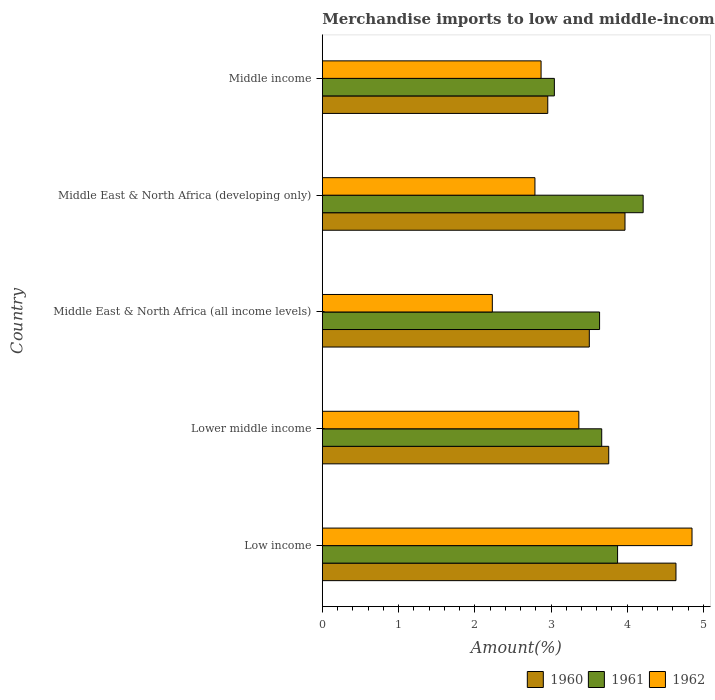How many different coloured bars are there?
Your answer should be very brief. 3. How many bars are there on the 2nd tick from the top?
Your answer should be compact. 3. What is the label of the 2nd group of bars from the top?
Offer a very short reply. Middle East & North Africa (developing only). What is the percentage of amount earned from merchandise imports in 1960 in Middle East & North Africa (developing only)?
Provide a short and direct response. 3.97. Across all countries, what is the maximum percentage of amount earned from merchandise imports in 1962?
Ensure brevity in your answer.  4.85. Across all countries, what is the minimum percentage of amount earned from merchandise imports in 1961?
Keep it short and to the point. 3.04. In which country was the percentage of amount earned from merchandise imports in 1960 maximum?
Your answer should be compact. Low income. In which country was the percentage of amount earned from merchandise imports in 1962 minimum?
Make the answer very short. Middle East & North Africa (all income levels). What is the total percentage of amount earned from merchandise imports in 1961 in the graph?
Offer a very short reply. 18.43. What is the difference between the percentage of amount earned from merchandise imports in 1961 in Low income and that in Middle East & North Africa (all income levels)?
Provide a short and direct response. 0.24. What is the difference between the percentage of amount earned from merchandise imports in 1962 in Lower middle income and the percentage of amount earned from merchandise imports in 1961 in Middle East & North Africa (developing only)?
Offer a terse response. -0.84. What is the average percentage of amount earned from merchandise imports in 1960 per country?
Your answer should be compact. 3.77. What is the difference between the percentage of amount earned from merchandise imports in 1962 and percentage of amount earned from merchandise imports in 1961 in Low income?
Your answer should be very brief. 0.98. In how many countries, is the percentage of amount earned from merchandise imports in 1961 greater than 3.4 %?
Give a very brief answer. 4. What is the ratio of the percentage of amount earned from merchandise imports in 1960 in Middle East & North Africa (developing only) to that in Middle income?
Your answer should be very brief. 1.34. What is the difference between the highest and the second highest percentage of amount earned from merchandise imports in 1961?
Offer a terse response. 0.34. What is the difference between the highest and the lowest percentage of amount earned from merchandise imports in 1962?
Your answer should be very brief. 2.62. In how many countries, is the percentage of amount earned from merchandise imports in 1962 greater than the average percentage of amount earned from merchandise imports in 1962 taken over all countries?
Give a very brief answer. 2. What does the 1st bar from the top in Middle income represents?
Provide a succinct answer. 1962. What does the 1st bar from the bottom in Lower middle income represents?
Your response must be concise. 1960. How many bars are there?
Provide a short and direct response. 15. Are the values on the major ticks of X-axis written in scientific E-notation?
Your answer should be very brief. No. Does the graph contain grids?
Give a very brief answer. No. Where does the legend appear in the graph?
Provide a succinct answer. Bottom right. How are the legend labels stacked?
Provide a succinct answer. Horizontal. What is the title of the graph?
Your answer should be very brief. Merchandise imports to low and middle-income economies within region. Does "1968" appear as one of the legend labels in the graph?
Your answer should be compact. No. What is the label or title of the X-axis?
Your answer should be very brief. Amount(%). What is the label or title of the Y-axis?
Provide a short and direct response. Country. What is the Amount(%) in 1960 in Low income?
Provide a short and direct response. 4.64. What is the Amount(%) of 1961 in Low income?
Your answer should be very brief. 3.87. What is the Amount(%) of 1962 in Low income?
Provide a short and direct response. 4.85. What is the Amount(%) of 1960 in Lower middle income?
Your response must be concise. 3.76. What is the Amount(%) in 1961 in Lower middle income?
Keep it short and to the point. 3.67. What is the Amount(%) in 1962 in Lower middle income?
Provide a succinct answer. 3.37. What is the Amount(%) of 1960 in Middle East & North Africa (all income levels)?
Give a very brief answer. 3.5. What is the Amount(%) in 1961 in Middle East & North Africa (all income levels)?
Make the answer very short. 3.64. What is the Amount(%) of 1962 in Middle East & North Africa (all income levels)?
Keep it short and to the point. 2.23. What is the Amount(%) in 1960 in Middle East & North Africa (developing only)?
Provide a short and direct response. 3.97. What is the Amount(%) of 1961 in Middle East & North Africa (developing only)?
Give a very brief answer. 4.21. What is the Amount(%) in 1962 in Middle East & North Africa (developing only)?
Provide a short and direct response. 2.79. What is the Amount(%) of 1960 in Middle income?
Give a very brief answer. 2.96. What is the Amount(%) in 1961 in Middle income?
Ensure brevity in your answer.  3.04. What is the Amount(%) of 1962 in Middle income?
Offer a terse response. 2.87. Across all countries, what is the maximum Amount(%) in 1960?
Offer a very short reply. 4.64. Across all countries, what is the maximum Amount(%) of 1961?
Give a very brief answer. 4.21. Across all countries, what is the maximum Amount(%) of 1962?
Provide a short and direct response. 4.85. Across all countries, what is the minimum Amount(%) in 1960?
Offer a terse response. 2.96. Across all countries, what is the minimum Amount(%) in 1961?
Ensure brevity in your answer.  3.04. Across all countries, what is the minimum Amount(%) in 1962?
Offer a very short reply. 2.23. What is the total Amount(%) in 1960 in the graph?
Provide a succinct answer. 18.83. What is the total Amount(%) of 1961 in the graph?
Your response must be concise. 18.43. What is the total Amount(%) of 1962 in the graph?
Offer a terse response. 16.11. What is the difference between the Amount(%) in 1960 in Low income and that in Lower middle income?
Offer a very short reply. 0.88. What is the difference between the Amount(%) of 1961 in Low income and that in Lower middle income?
Your response must be concise. 0.21. What is the difference between the Amount(%) in 1962 in Low income and that in Lower middle income?
Provide a short and direct response. 1.48. What is the difference between the Amount(%) in 1960 in Low income and that in Middle East & North Africa (all income levels)?
Keep it short and to the point. 1.14. What is the difference between the Amount(%) of 1961 in Low income and that in Middle East & North Africa (all income levels)?
Provide a succinct answer. 0.24. What is the difference between the Amount(%) of 1962 in Low income and that in Middle East & North Africa (all income levels)?
Offer a very short reply. 2.62. What is the difference between the Amount(%) in 1960 in Low income and that in Middle East & North Africa (developing only)?
Your answer should be compact. 0.67. What is the difference between the Amount(%) in 1961 in Low income and that in Middle East & North Africa (developing only)?
Your answer should be compact. -0.34. What is the difference between the Amount(%) in 1962 in Low income and that in Middle East & North Africa (developing only)?
Make the answer very short. 2.06. What is the difference between the Amount(%) of 1960 in Low income and that in Middle income?
Provide a succinct answer. 1.68. What is the difference between the Amount(%) of 1961 in Low income and that in Middle income?
Your answer should be very brief. 0.83. What is the difference between the Amount(%) of 1962 in Low income and that in Middle income?
Ensure brevity in your answer.  1.98. What is the difference between the Amount(%) of 1960 in Lower middle income and that in Middle East & North Africa (all income levels)?
Your answer should be very brief. 0.25. What is the difference between the Amount(%) of 1961 in Lower middle income and that in Middle East & North Africa (all income levels)?
Keep it short and to the point. 0.03. What is the difference between the Amount(%) in 1962 in Lower middle income and that in Middle East & North Africa (all income levels)?
Offer a very short reply. 1.14. What is the difference between the Amount(%) of 1960 in Lower middle income and that in Middle East & North Africa (developing only)?
Offer a very short reply. -0.21. What is the difference between the Amount(%) in 1961 in Lower middle income and that in Middle East & North Africa (developing only)?
Offer a terse response. -0.54. What is the difference between the Amount(%) in 1962 in Lower middle income and that in Middle East & North Africa (developing only)?
Make the answer very short. 0.58. What is the difference between the Amount(%) in 1960 in Lower middle income and that in Middle income?
Provide a succinct answer. 0.8. What is the difference between the Amount(%) in 1961 in Lower middle income and that in Middle income?
Keep it short and to the point. 0.62. What is the difference between the Amount(%) in 1962 in Lower middle income and that in Middle income?
Offer a terse response. 0.5. What is the difference between the Amount(%) in 1960 in Middle East & North Africa (all income levels) and that in Middle East & North Africa (developing only)?
Offer a terse response. -0.47. What is the difference between the Amount(%) of 1961 in Middle East & North Africa (all income levels) and that in Middle East & North Africa (developing only)?
Give a very brief answer. -0.57. What is the difference between the Amount(%) in 1962 in Middle East & North Africa (all income levels) and that in Middle East & North Africa (developing only)?
Your response must be concise. -0.56. What is the difference between the Amount(%) in 1960 in Middle East & North Africa (all income levels) and that in Middle income?
Keep it short and to the point. 0.55. What is the difference between the Amount(%) of 1961 in Middle East & North Africa (all income levels) and that in Middle income?
Your answer should be compact. 0.59. What is the difference between the Amount(%) of 1962 in Middle East & North Africa (all income levels) and that in Middle income?
Make the answer very short. -0.64. What is the difference between the Amount(%) in 1960 in Middle East & North Africa (developing only) and that in Middle income?
Your answer should be very brief. 1.01. What is the difference between the Amount(%) of 1961 in Middle East & North Africa (developing only) and that in Middle income?
Your response must be concise. 1.16. What is the difference between the Amount(%) in 1962 in Middle East & North Africa (developing only) and that in Middle income?
Make the answer very short. -0.08. What is the difference between the Amount(%) in 1960 in Low income and the Amount(%) in 1962 in Lower middle income?
Provide a succinct answer. 1.27. What is the difference between the Amount(%) of 1961 in Low income and the Amount(%) of 1962 in Lower middle income?
Your answer should be compact. 0.51. What is the difference between the Amount(%) in 1960 in Low income and the Amount(%) in 1961 in Middle East & North Africa (all income levels)?
Your answer should be very brief. 1. What is the difference between the Amount(%) of 1960 in Low income and the Amount(%) of 1962 in Middle East & North Africa (all income levels)?
Provide a short and direct response. 2.41. What is the difference between the Amount(%) in 1961 in Low income and the Amount(%) in 1962 in Middle East & North Africa (all income levels)?
Offer a very short reply. 1.64. What is the difference between the Amount(%) in 1960 in Low income and the Amount(%) in 1961 in Middle East & North Africa (developing only)?
Your answer should be compact. 0.43. What is the difference between the Amount(%) in 1960 in Low income and the Amount(%) in 1962 in Middle East & North Africa (developing only)?
Your answer should be very brief. 1.85. What is the difference between the Amount(%) of 1961 in Low income and the Amount(%) of 1962 in Middle East & North Africa (developing only)?
Offer a terse response. 1.08. What is the difference between the Amount(%) in 1960 in Low income and the Amount(%) in 1961 in Middle income?
Ensure brevity in your answer.  1.6. What is the difference between the Amount(%) of 1960 in Low income and the Amount(%) of 1962 in Middle income?
Your answer should be very brief. 1.77. What is the difference between the Amount(%) of 1960 in Lower middle income and the Amount(%) of 1961 in Middle East & North Africa (all income levels)?
Provide a succinct answer. 0.12. What is the difference between the Amount(%) of 1960 in Lower middle income and the Amount(%) of 1962 in Middle East & North Africa (all income levels)?
Offer a terse response. 1.53. What is the difference between the Amount(%) of 1961 in Lower middle income and the Amount(%) of 1962 in Middle East & North Africa (all income levels)?
Your answer should be very brief. 1.44. What is the difference between the Amount(%) of 1960 in Lower middle income and the Amount(%) of 1961 in Middle East & North Africa (developing only)?
Give a very brief answer. -0.45. What is the difference between the Amount(%) in 1961 in Lower middle income and the Amount(%) in 1962 in Middle East & North Africa (developing only)?
Your answer should be very brief. 0.88. What is the difference between the Amount(%) in 1960 in Lower middle income and the Amount(%) in 1961 in Middle income?
Your answer should be very brief. 0.71. What is the difference between the Amount(%) of 1960 in Lower middle income and the Amount(%) of 1962 in Middle income?
Ensure brevity in your answer.  0.89. What is the difference between the Amount(%) in 1961 in Lower middle income and the Amount(%) in 1962 in Middle income?
Your answer should be very brief. 0.8. What is the difference between the Amount(%) in 1960 in Middle East & North Africa (all income levels) and the Amount(%) in 1961 in Middle East & North Africa (developing only)?
Give a very brief answer. -0.71. What is the difference between the Amount(%) of 1960 in Middle East & North Africa (all income levels) and the Amount(%) of 1962 in Middle East & North Africa (developing only)?
Your answer should be very brief. 0.71. What is the difference between the Amount(%) of 1961 in Middle East & North Africa (all income levels) and the Amount(%) of 1962 in Middle East & North Africa (developing only)?
Provide a succinct answer. 0.85. What is the difference between the Amount(%) in 1960 in Middle East & North Africa (all income levels) and the Amount(%) in 1961 in Middle income?
Give a very brief answer. 0.46. What is the difference between the Amount(%) of 1960 in Middle East & North Africa (all income levels) and the Amount(%) of 1962 in Middle income?
Keep it short and to the point. 0.63. What is the difference between the Amount(%) of 1961 in Middle East & North Africa (all income levels) and the Amount(%) of 1962 in Middle income?
Your response must be concise. 0.77. What is the difference between the Amount(%) of 1960 in Middle East & North Africa (developing only) and the Amount(%) of 1961 in Middle income?
Offer a very short reply. 0.93. What is the difference between the Amount(%) in 1960 in Middle East & North Africa (developing only) and the Amount(%) in 1962 in Middle income?
Your response must be concise. 1.1. What is the difference between the Amount(%) in 1961 in Middle East & North Africa (developing only) and the Amount(%) in 1962 in Middle income?
Keep it short and to the point. 1.34. What is the average Amount(%) of 1960 per country?
Ensure brevity in your answer.  3.77. What is the average Amount(%) in 1961 per country?
Your answer should be compact. 3.69. What is the average Amount(%) of 1962 per country?
Ensure brevity in your answer.  3.22. What is the difference between the Amount(%) of 1960 and Amount(%) of 1961 in Low income?
Provide a short and direct response. 0.77. What is the difference between the Amount(%) of 1960 and Amount(%) of 1962 in Low income?
Ensure brevity in your answer.  -0.21. What is the difference between the Amount(%) in 1961 and Amount(%) in 1962 in Low income?
Provide a short and direct response. -0.98. What is the difference between the Amount(%) of 1960 and Amount(%) of 1961 in Lower middle income?
Keep it short and to the point. 0.09. What is the difference between the Amount(%) of 1960 and Amount(%) of 1962 in Lower middle income?
Your response must be concise. 0.39. What is the difference between the Amount(%) in 1961 and Amount(%) in 1962 in Lower middle income?
Provide a succinct answer. 0.3. What is the difference between the Amount(%) of 1960 and Amount(%) of 1961 in Middle East & North Africa (all income levels)?
Keep it short and to the point. -0.13. What is the difference between the Amount(%) of 1960 and Amount(%) of 1962 in Middle East & North Africa (all income levels)?
Make the answer very short. 1.27. What is the difference between the Amount(%) in 1961 and Amount(%) in 1962 in Middle East & North Africa (all income levels)?
Make the answer very short. 1.41. What is the difference between the Amount(%) in 1960 and Amount(%) in 1961 in Middle East & North Africa (developing only)?
Make the answer very short. -0.24. What is the difference between the Amount(%) of 1960 and Amount(%) of 1962 in Middle East & North Africa (developing only)?
Your response must be concise. 1.18. What is the difference between the Amount(%) in 1961 and Amount(%) in 1962 in Middle East & North Africa (developing only)?
Make the answer very short. 1.42. What is the difference between the Amount(%) of 1960 and Amount(%) of 1961 in Middle income?
Ensure brevity in your answer.  -0.09. What is the difference between the Amount(%) in 1960 and Amount(%) in 1962 in Middle income?
Your answer should be very brief. 0.09. What is the difference between the Amount(%) in 1961 and Amount(%) in 1962 in Middle income?
Your response must be concise. 0.17. What is the ratio of the Amount(%) in 1960 in Low income to that in Lower middle income?
Give a very brief answer. 1.23. What is the ratio of the Amount(%) in 1961 in Low income to that in Lower middle income?
Offer a very short reply. 1.06. What is the ratio of the Amount(%) of 1962 in Low income to that in Lower middle income?
Ensure brevity in your answer.  1.44. What is the ratio of the Amount(%) in 1960 in Low income to that in Middle East & North Africa (all income levels)?
Give a very brief answer. 1.32. What is the ratio of the Amount(%) of 1961 in Low income to that in Middle East & North Africa (all income levels)?
Offer a very short reply. 1.06. What is the ratio of the Amount(%) of 1962 in Low income to that in Middle East & North Africa (all income levels)?
Offer a terse response. 2.17. What is the ratio of the Amount(%) of 1960 in Low income to that in Middle East & North Africa (developing only)?
Provide a succinct answer. 1.17. What is the ratio of the Amount(%) in 1961 in Low income to that in Middle East & North Africa (developing only)?
Your answer should be compact. 0.92. What is the ratio of the Amount(%) of 1962 in Low income to that in Middle East & North Africa (developing only)?
Offer a terse response. 1.74. What is the ratio of the Amount(%) of 1960 in Low income to that in Middle income?
Offer a terse response. 1.57. What is the ratio of the Amount(%) of 1961 in Low income to that in Middle income?
Make the answer very short. 1.27. What is the ratio of the Amount(%) in 1962 in Low income to that in Middle income?
Give a very brief answer. 1.69. What is the ratio of the Amount(%) in 1960 in Lower middle income to that in Middle East & North Africa (all income levels)?
Your answer should be compact. 1.07. What is the ratio of the Amount(%) in 1962 in Lower middle income to that in Middle East & North Africa (all income levels)?
Provide a succinct answer. 1.51. What is the ratio of the Amount(%) in 1960 in Lower middle income to that in Middle East & North Africa (developing only)?
Offer a very short reply. 0.95. What is the ratio of the Amount(%) of 1961 in Lower middle income to that in Middle East & North Africa (developing only)?
Give a very brief answer. 0.87. What is the ratio of the Amount(%) of 1962 in Lower middle income to that in Middle East & North Africa (developing only)?
Give a very brief answer. 1.21. What is the ratio of the Amount(%) of 1960 in Lower middle income to that in Middle income?
Provide a succinct answer. 1.27. What is the ratio of the Amount(%) of 1961 in Lower middle income to that in Middle income?
Keep it short and to the point. 1.2. What is the ratio of the Amount(%) in 1962 in Lower middle income to that in Middle income?
Your answer should be very brief. 1.17. What is the ratio of the Amount(%) in 1960 in Middle East & North Africa (all income levels) to that in Middle East & North Africa (developing only)?
Keep it short and to the point. 0.88. What is the ratio of the Amount(%) of 1961 in Middle East & North Africa (all income levels) to that in Middle East & North Africa (developing only)?
Provide a short and direct response. 0.86. What is the ratio of the Amount(%) in 1962 in Middle East & North Africa (all income levels) to that in Middle East & North Africa (developing only)?
Ensure brevity in your answer.  0.8. What is the ratio of the Amount(%) of 1960 in Middle East & North Africa (all income levels) to that in Middle income?
Ensure brevity in your answer.  1.18. What is the ratio of the Amount(%) of 1961 in Middle East & North Africa (all income levels) to that in Middle income?
Ensure brevity in your answer.  1.19. What is the ratio of the Amount(%) of 1962 in Middle East & North Africa (all income levels) to that in Middle income?
Provide a succinct answer. 0.78. What is the ratio of the Amount(%) in 1960 in Middle East & North Africa (developing only) to that in Middle income?
Offer a terse response. 1.34. What is the ratio of the Amount(%) in 1961 in Middle East & North Africa (developing only) to that in Middle income?
Provide a succinct answer. 1.38. What is the difference between the highest and the second highest Amount(%) in 1960?
Your response must be concise. 0.67. What is the difference between the highest and the second highest Amount(%) of 1961?
Your answer should be very brief. 0.34. What is the difference between the highest and the second highest Amount(%) of 1962?
Provide a short and direct response. 1.48. What is the difference between the highest and the lowest Amount(%) in 1960?
Make the answer very short. 1.68. What is the difference between the highest and the lowest Amount(%) of 1961?
Keep it short and to the point. 1.16. What is the difference between the highest and the lowest Amount(%) in 1962?
Your response must be concise. 2.62. 